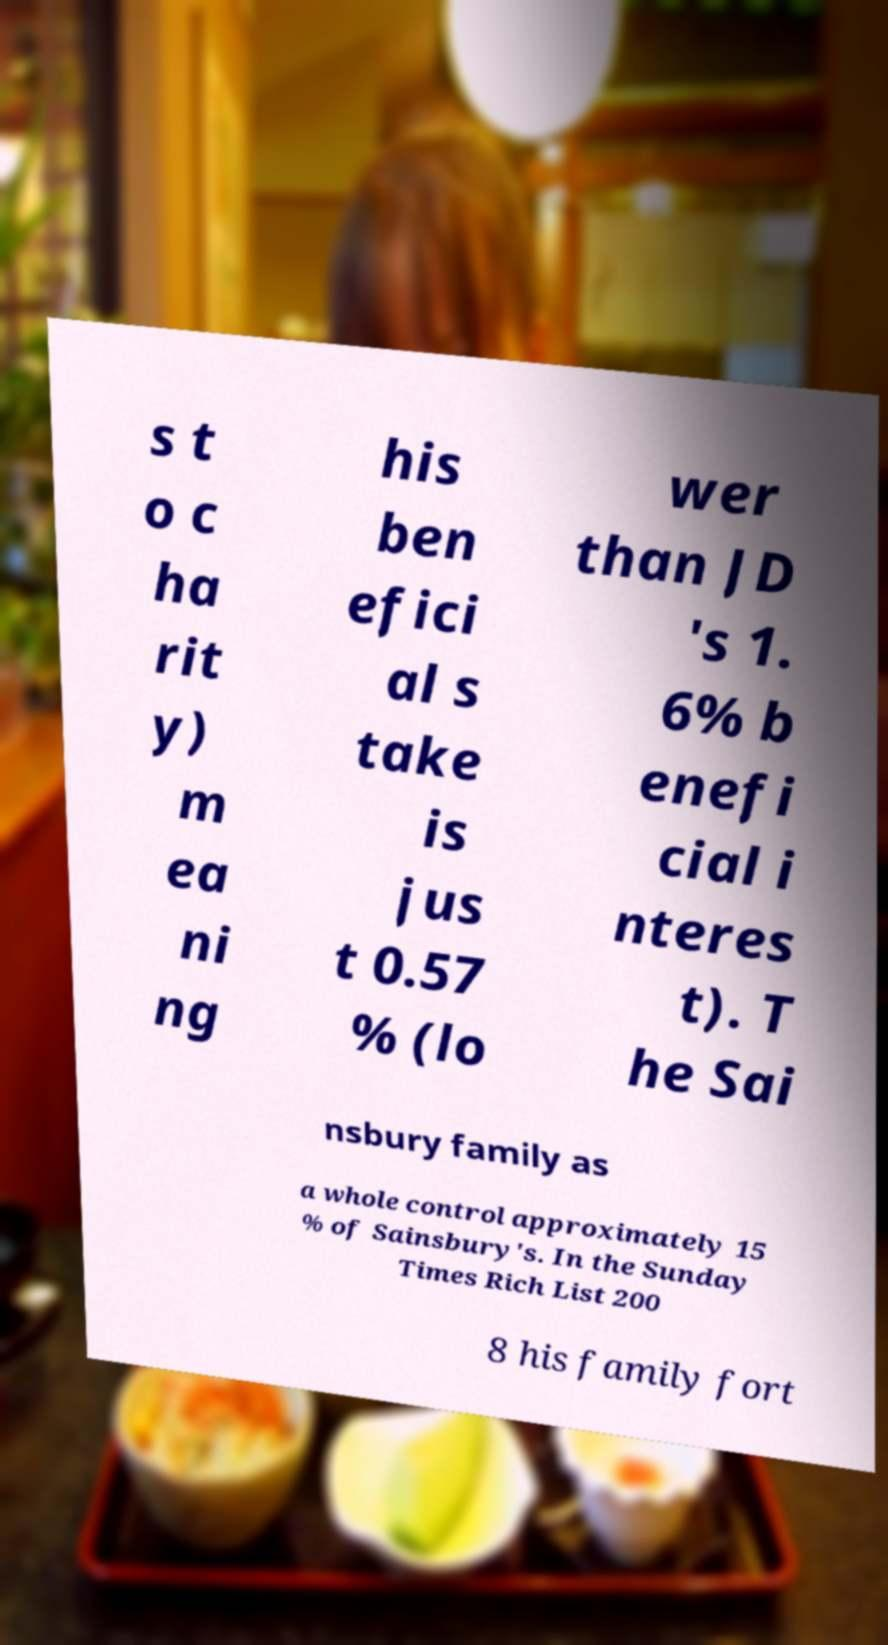Can you read and provide the text displayed in the image?This photo seems to have some interesting text. Can you extract and type it out for me? s t o c ha rit y) m ea ni ng his ben efici al s take is jus t 0.57 % (lo wer than JD 's 1. 6% b enefi cial i nteres t). T he Sai nsbury family as a whole control approximately 15 % of Sainsbury's. In the Sunday Times Rich List 200 8 his family fort 